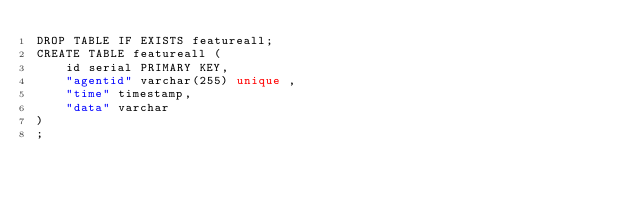Convert code to text. <code><loc_0><loc_0><loc_500><loc_500><_SQL_>DROP TABLE IF EXISTS featureall;
CREATE TABLE featureall (
    id serial PRIMARY KEY,
    "agentid" varchar(255) unique ,
    "time" timestamp,
    "data" varchar
)
;</code> 